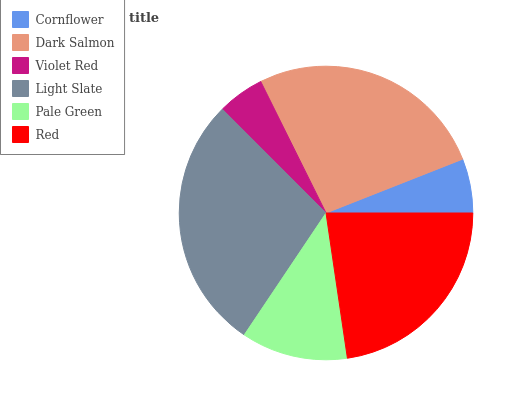Is Violet Red the minimum?
Answer yes or no. Yes. Is Light Slate the maximum?
Answer yes or no. Yes. Is Dark Salmon the minimum?
Answer yes or no. No. Is Dark Salmon the maximum?
Answer yes or no. No. Is Dark Salmon greater than Cornflower?
Answer yes or no. Yes. Is Cornflower less than Dark Salmon?
Answer yes or no. Yes. Is Cornflower greater than Dark Salmon?
Answer yes or no. No. Is Dark Salmon less than Cornflower?
Answer yes or no. No. Is Red the high median?
Answer yes or no. Yes. Is Pale Green the low median?
Answer yes or no. Yes. Is Violet Red the high median?
Answer yes or no. No. Is Dark Salmon the low median?
Answer yes or no. No. 